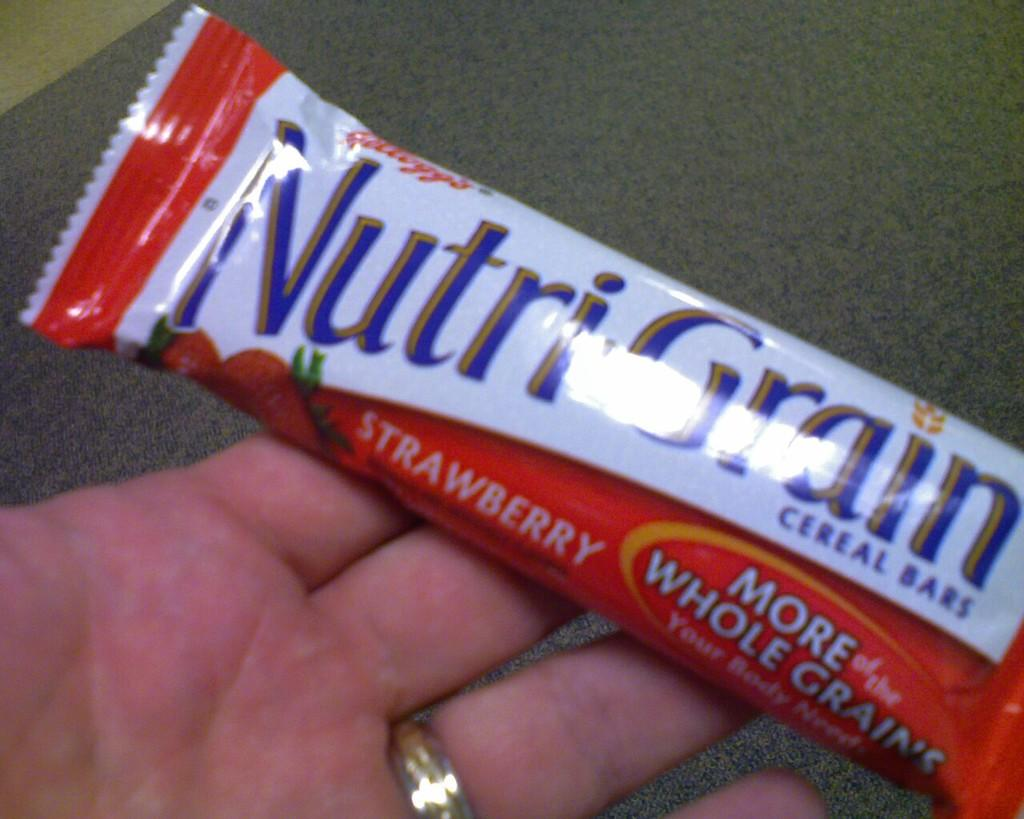What is the main subject of the image? The main subject of the image is a chocolate. Who is holding the chocolate in the image? The chocolate is being held by a person. What is the surface at the bottom of the image? There is a carpet at the bottom of the image. How much does the squirrel weigh in the image? There is no squirrel present in the image, so its weight cannot be determined. 